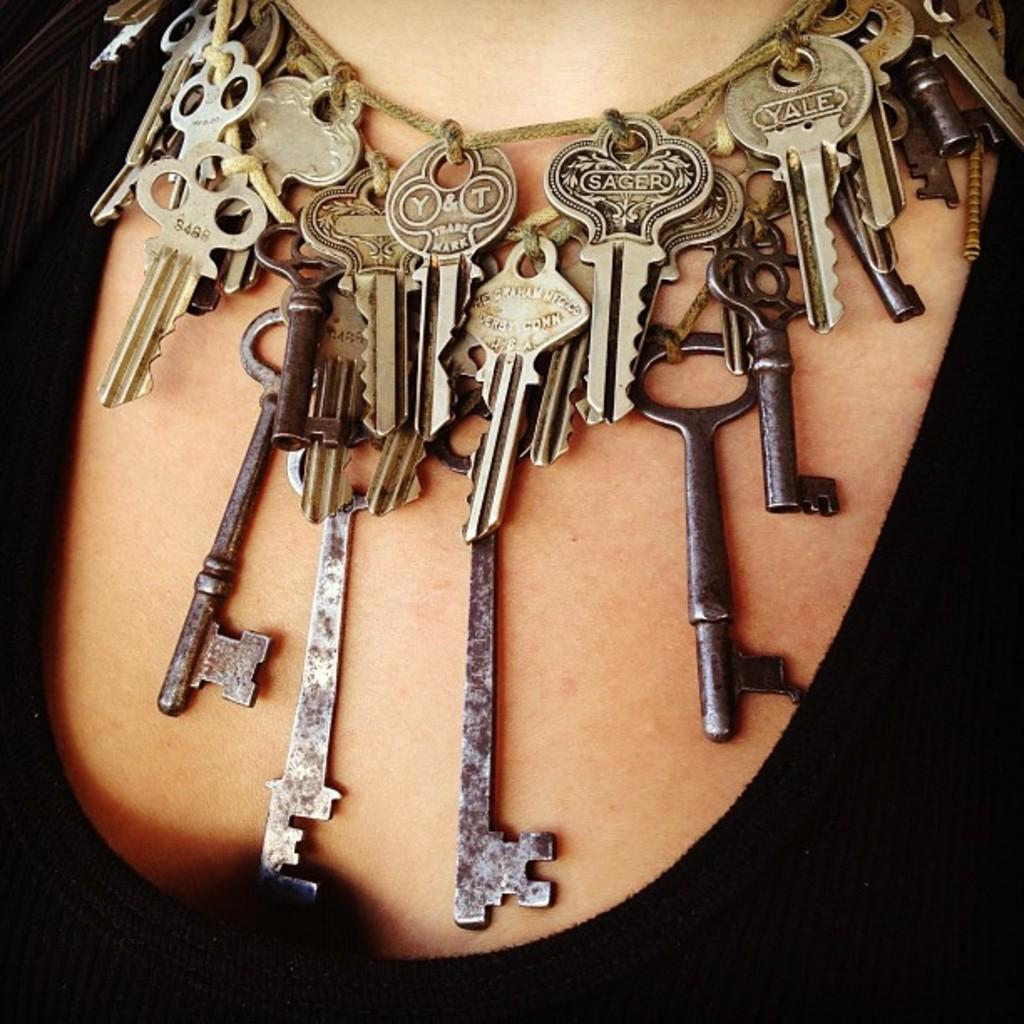What is the main object in the image? There is a chain made up of keys in the image. How is the chain being worn or displayed? The chain is placed around a person's neck. What is the person wearing in the image? The person is wearing a black dress. What type of whip is the laborer using in the image? There is no laborer or whip present in the image. 